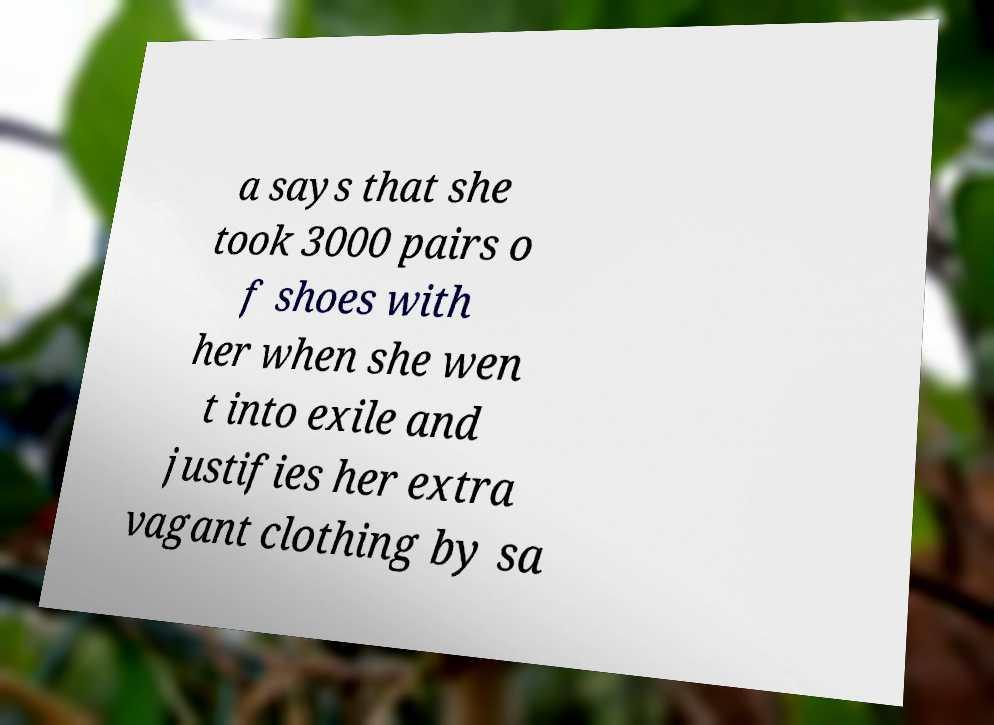I need the written content from this picture converted into text. Can you do that? a says that she took 3000 pairs o f shoes with her when she wen t into exile and justifies her extra vagant clothing by sa 